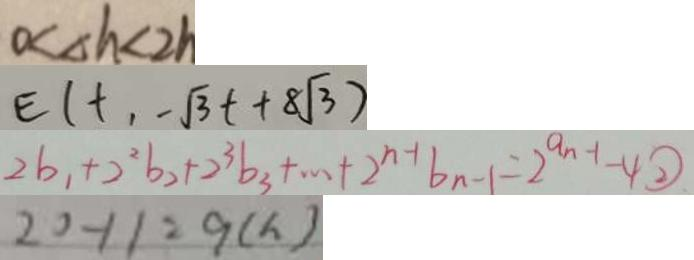<formula> <loc_0><loc_0><loc_500><loc_500>0 < \Delta h < 2 h 
 E ( t , - \sqrt { 3 } t + 8 \sqrt { 3 } ) 
 2 b _ { 1 } + 2 ^ { 2 } b _ { 2 } + 2 ^ { 3 } b _ { 3 } + \cdots + 2 ^ { n - 1 } b _ { n - 1 } = 2 ^ { a n - 1 } - 4 \textcircled { 2 } 
 2 0 - 1 1 = 9 ( h )</formula> 